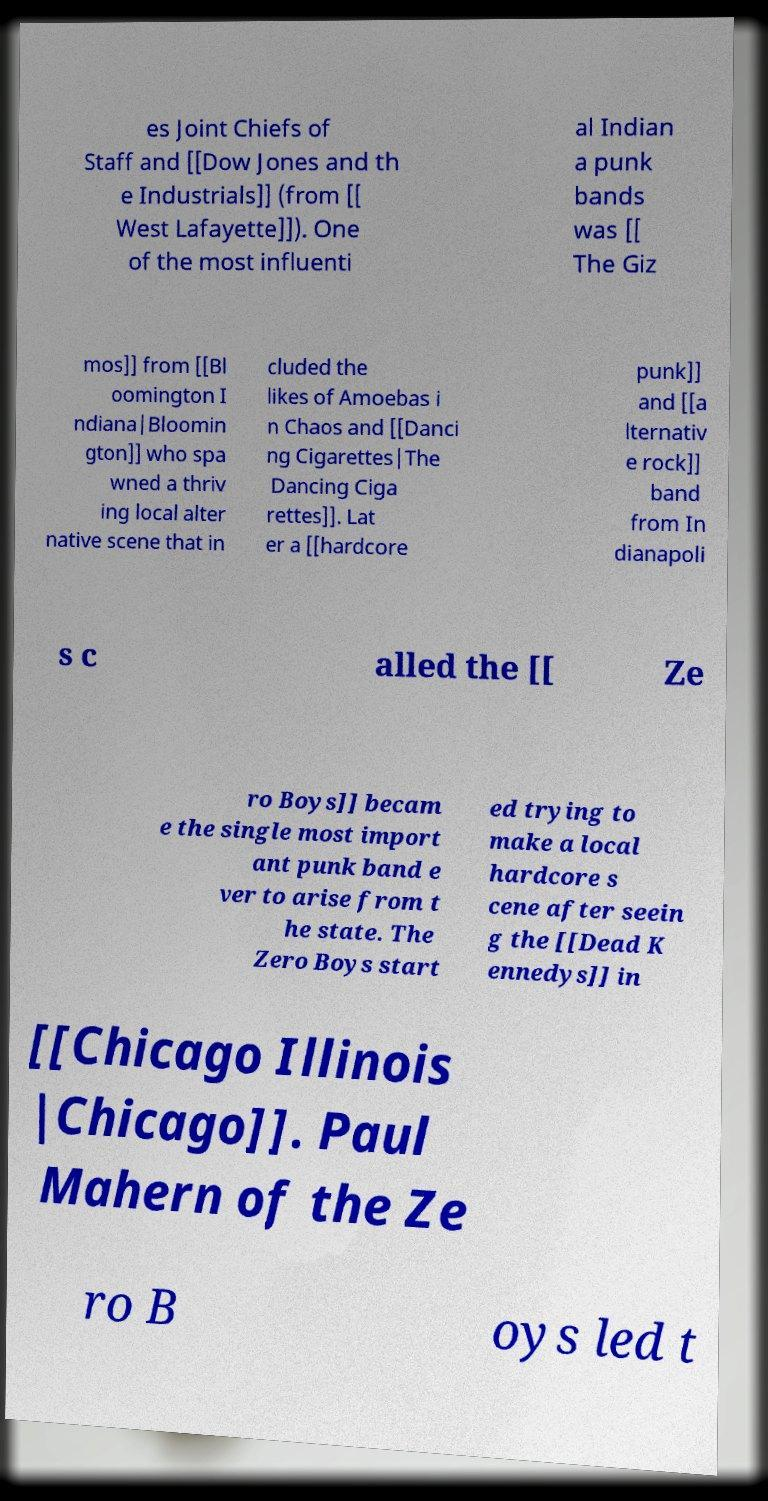Can you read and provide the text displayed in the image?This photo seems to have some interesting text. Can you extract and type it out for me? es Joint Chiefs of Staff and [[Dow Jones and th e Industrials]] (from [[ West Lafayette]]). One of the most influenti al Indian a punk bands was [[ The Giz mos]] from [[Bl oomington I ndiana|Bloomin gton]] who spa wned a thriv ing local alter native scene that in cluded the likes of Amoebas i n Chaos and [[Danci ng Cigarettes|The Dancing Ciga rettes]]. Lat er a [[hardcore punk]] and [[a lternativ e rock]] band from In dianapoli s c alled the [[ Ze ro Boys]] becam e the single most import ant punk band e ver to arise from t he state. The Zero Boys start ed trying to make a local hardcore s cene after seein g the [[Dead K ennedys]] in [[Chicago Illinois |Chicago]]. Paul Mahern of the Ze ro B oys led t 